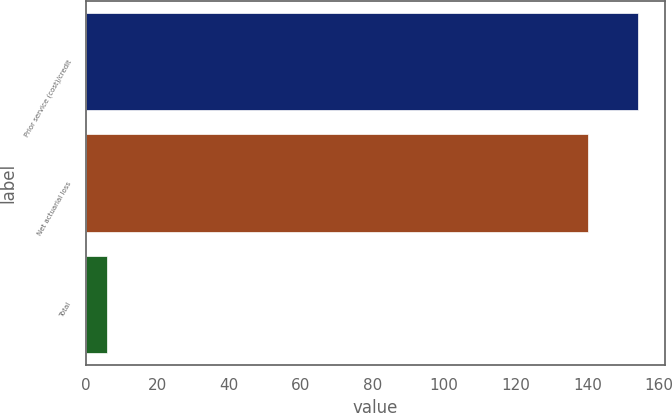Convert chart to OTSL. <chart><loc_0><loc_0><loc_500><loc_500><bar_chart><fcel>Prior service (cost)/credit<fcel>Net actuarial loss<fcel>Total<nl><fcel>154<fcel>140<fcel>6<nl></chart> 